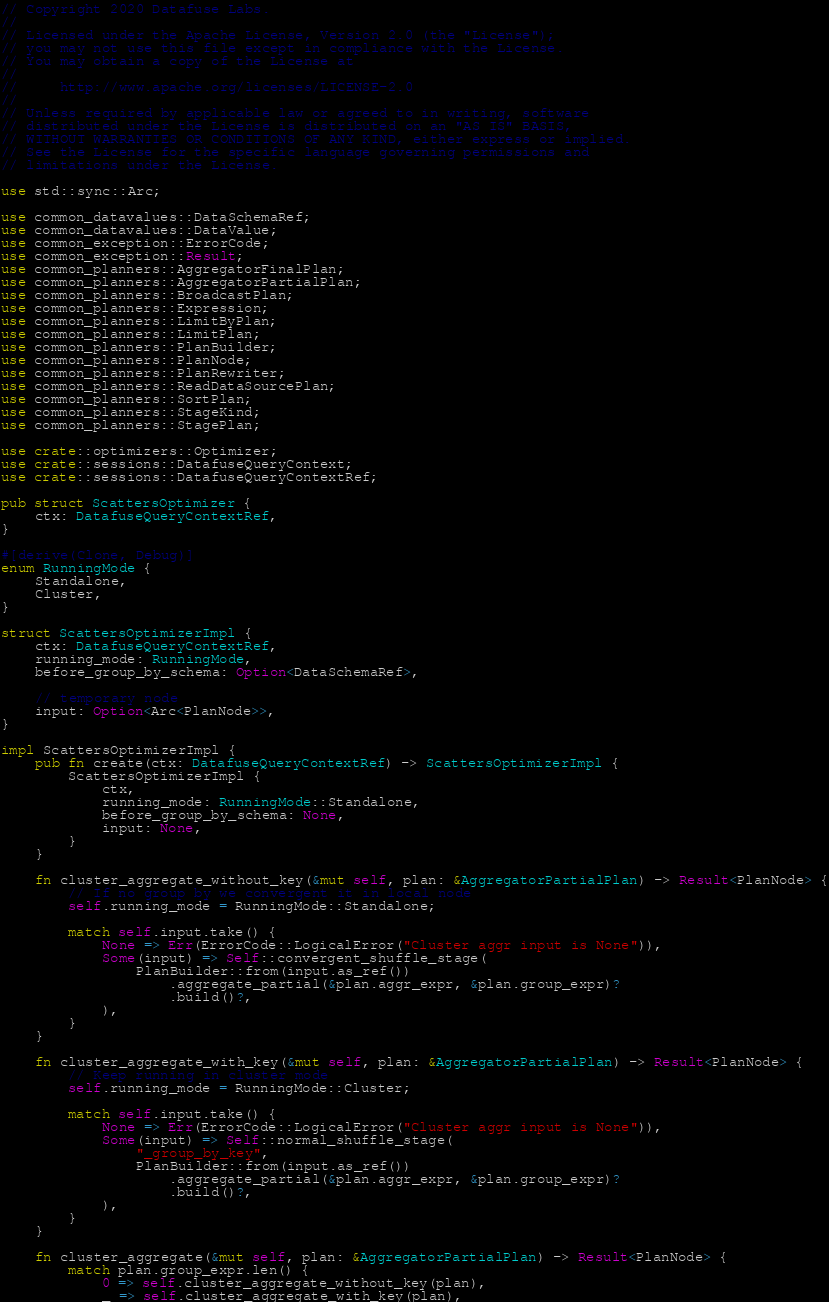Convert code to text. <code><loc_0><loc_0><loc_500><loc_500><_Rust_>// Copyright 2020 Datafuse Labs.
//
// Licensed under the Apache License, Version 2.0 (the "License");
// you may not use this file except in compliance with the License.
// You may obtain a copy of the License at
//
//     http://www.apache.org/licenses/LICENSE-2.0
//
// Unless required by applicable law or agreed to in writing, software
// distributed under the License is distributed on an "AS IS" BASIS,
// WITHOUT WARRANTIES OR CONDITIONS OF ANY KIND, either express or implied.
// See the License for the specific language governing permissions and
// limitations under the License.

use std::sync::Arc;

use common_datavalues::DataSchemaRef;
use common_datavalues::DataValue;
use common_exception::ErrorCode;
use common_exception::Result;
use common_planners::AggregatorFinalPlan;
use common_planners::AggregatorPartialPlan;
use common_planners::BroadcastPlan;
use common_planners::Expression;
use common_planners::LimitByPlan;
use common_planners::LimitPlan;
use common_planners::PlanBuilder;
use common_planners::PlanNode;
use common_planners::PlanRewriter;
use common_planners::ReadDataSourcePlan;
use common_planners::SortPlan;
use common_planners::StageKind;
use common_planners::StagePlan;

use crate::optimizers::Optimizer;
use crate::sessions::DatafuseQueryContext;
use crate::sessions::DatafuseQueryContextRef;

pub struct ScattersOptimizer {
    ctx: DatafuseQueryContextRef,
}

#[derive(Clone, Debug)]
enum RunningMode {
    Standalone,
    Cluster,
}

struct ScattersOptimizerImpl {
    ctx: DatafuseQueryContextRef,
    running_mode: RunningMode,
    before_group_by_schema: Option<DataSchemaRef>,

    // temporary node
    input: Option<Arc<PlanNode>>,
}

impl ScattersOptimizerImpl {
    pub fn create(ctx: DatafuseQueryContextRef) -> ScattersOptimizerImpl {
        ScattersOptimizerImpl {
            ctx,
            running_mode: RunningMode::Standalone,
            before_group_by_schema: None,
            input: None,
        }
    }

    fn cluster_aggregate_without_key(&mut self, plan: &AggregatorPartialPlan) -> Result<PlanNode> {
        // If no group by we convergent it in local node
        self.running_mode = RunningMode::Standalone;

        match self.input.take() {
            None => Err(ErrorCode::LogicalError("Cluster aggr input is None")),
            Some(input) => Self::convergent_shuffle_stage(
                PlanBuilder::from(input.as_ref())
                    .aggregate_partial(&plan.aggr_expr, &plan.group_expr)?
                    .build()?,
            ),
        }
    }

    fn cluster_aggregate_with_key(&mut self, plan: &AggregatorPartialPlan) -> Result<PlanNode> {
        // Keep running in cluster mode
        self.running_mode = RunningMode::Cluster;

        match self.input.take() {
            None => Err(ErrorCode::LogicalError("Cluster aggr input is None")),
            Some(input) => Self::normal_shuffle_stage(
                "_group_by_key",
                PlanBuilder::from(input.as_ref())
                    .aggregate_partial(&plan.aggr_expr, &plan.group_expr)?
                    .build()?,
            ),
        }
    }

    fn cluster_aggregate(&mut self, plan: &AggregatorPartialPlan) -> Result<PlanNode> {
        match plan.group_expr.len() {
            0 => self.cluster_aggregate_without_key(plan),
            _ => self.cluster_aggregate_with_key(plan),</code> 